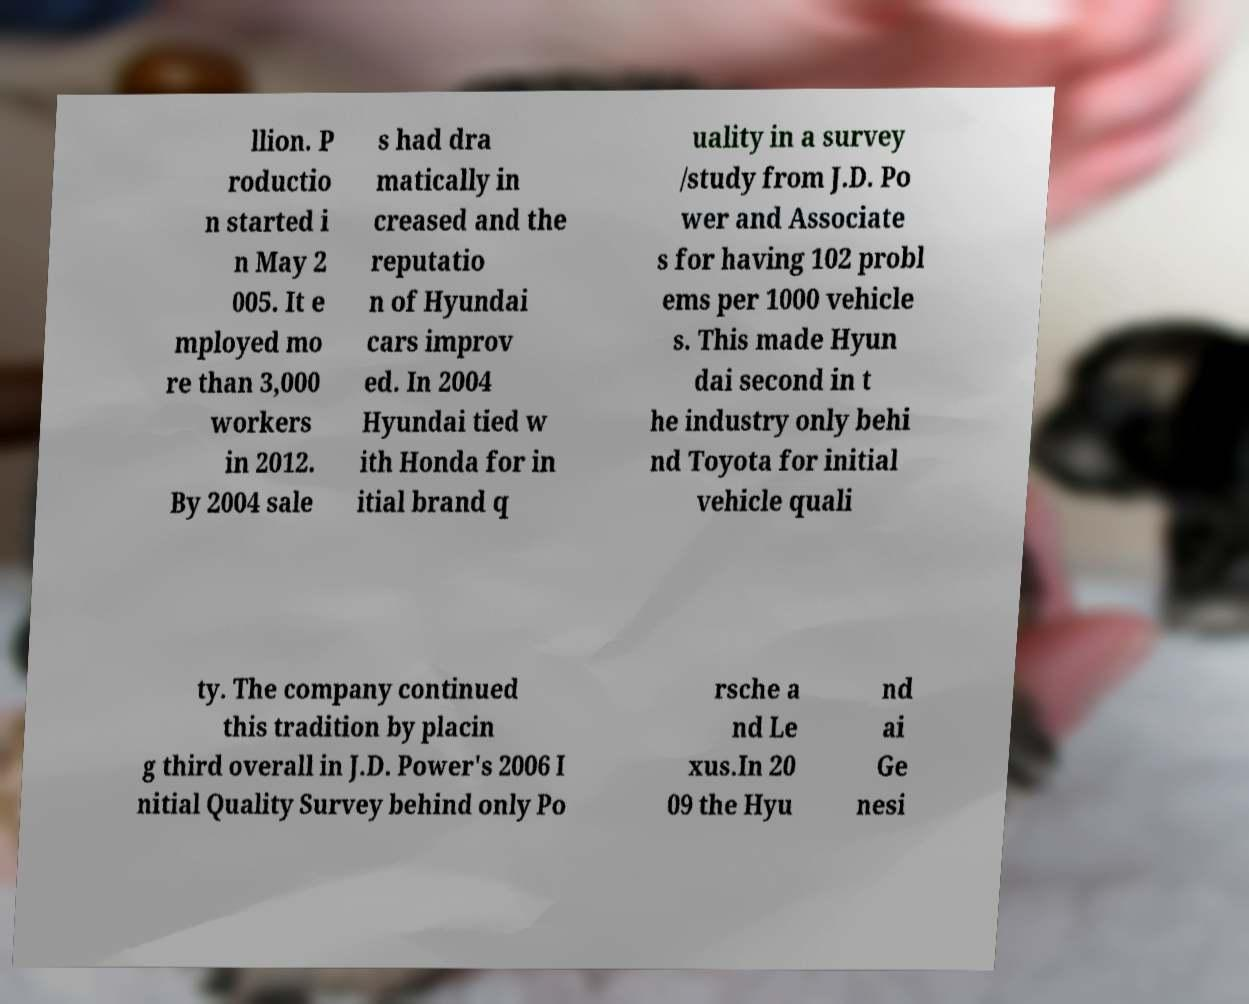Can you accurately transcribe the text from the provided image for me? llion. P roductio n started i n May 2 005. It e mployed mo re than 3,000 workers in 2012. By 2004 sale s had dra matically in creased and the reputatio n of Hyundai cars improv ed. In 2004 Hyundai tied w ith Honda for in itial brand q uality in a survey /study from J.D. Po wer and Associate s for having 102 probl ems per 1000 vehicle s. This made Hyun dai second in t he industry only behi nd Toyota for initial vehicle quali ty. The company continued this tradition by placin g third overall in J.D. Power's 2006 I nitial Quality Survey behind only Po rsche a nd Le xus.In 20 09 the Hyu nd ai Ge nesi 